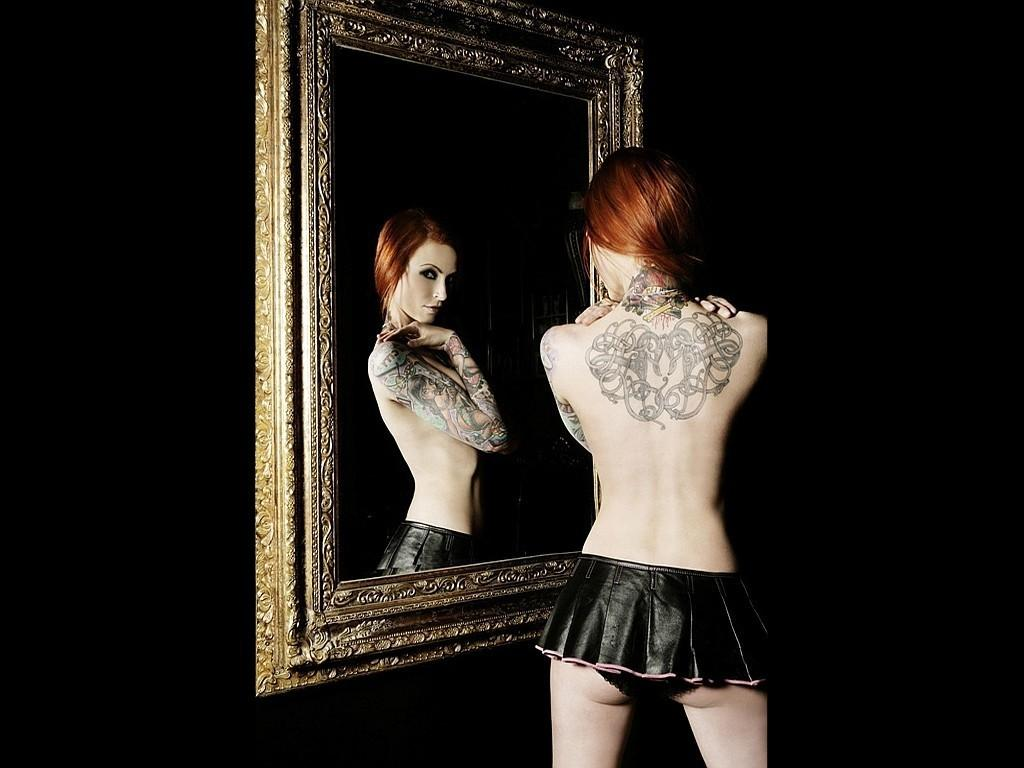Who is the main subject in the image? There is a woman in the image. What is the woman doing in the image? The woman is standing in front of a mirror. What can be observed about the background of the image? The background of the image is dark. What type of hammer is the woman using to process mail in the image? There is no hammer or mail in the image; the woman is standing in front of a mirror. 